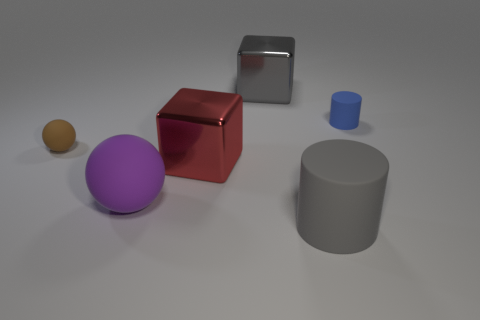Can you identify the lighting source in the image? While the specific lighting source isn't visible in the image, the shadows and reflections suggest that there is a diffuse overhead light source casting light from above, possibly slightly in front of the objects, with ambient light contributing to the softer shadows. 